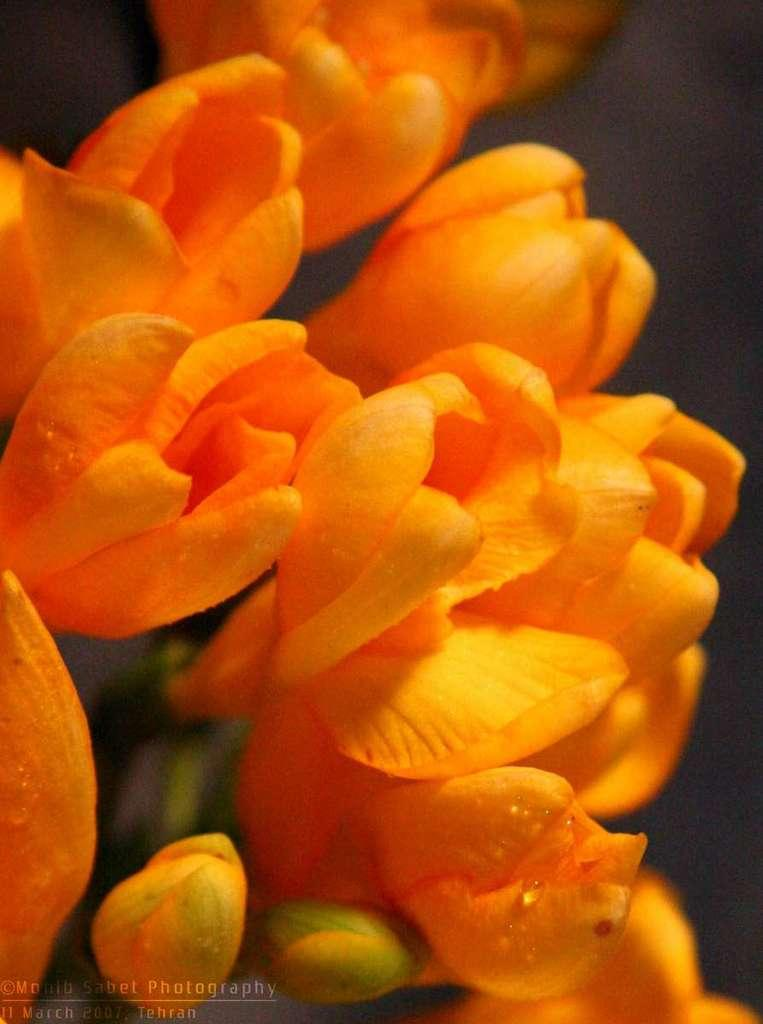What type of flora is present in the image? There are flowers in the image. What color are the flowers? The flowers are orange in color. What is the color of the background in the image? The background in the image is black. How many lizards can be seen in the image? There are no lizards present in the image; it features flowers with a black background. 